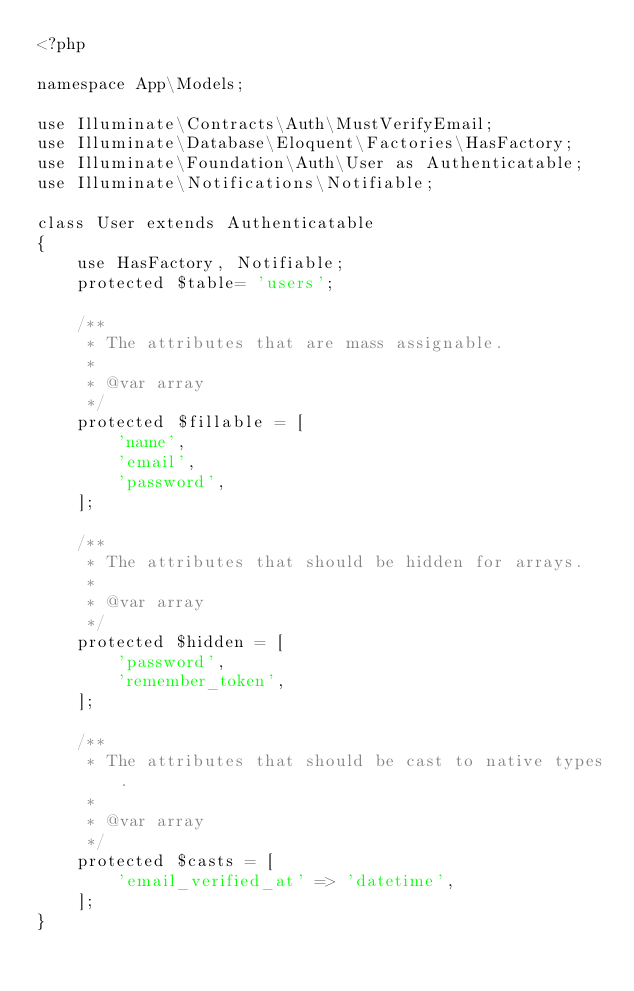Convert code to text. <code><loc_0><loc_0><loc_500><loc_500><_PHP_><?php

namespace App\Models;

use Illuminate\Contracts\Auth\MustVerifyEmail;
use Illuminate\Database\Eloquent\Factories\HasFactory;
use Illuminate\Foundation\Auth\User as Authenticatable;
use Illuminate\Notifications\Notifiable;

class User extends Authenticatable
{
    use HasFactory, Notifiable;
    protected $table= 'users';

    /**
     * The attributes that are mass assignable.
     *
     * @var array
     */
    protected $fillable = [
        'name',
        'email',
        'password',
    ];

    /**
     * The attributes that should be hidden for arrays.
     *
     * @var array
     */
    protected $hidden = [
        'password',
        'remember_token',
    ];

    /**
     * The attributes that should be cast to native types.
     *
     * @var array
     */
    protected $casts = [
        'email_verified_at' => 'datetime',
    ];
}
</code> 